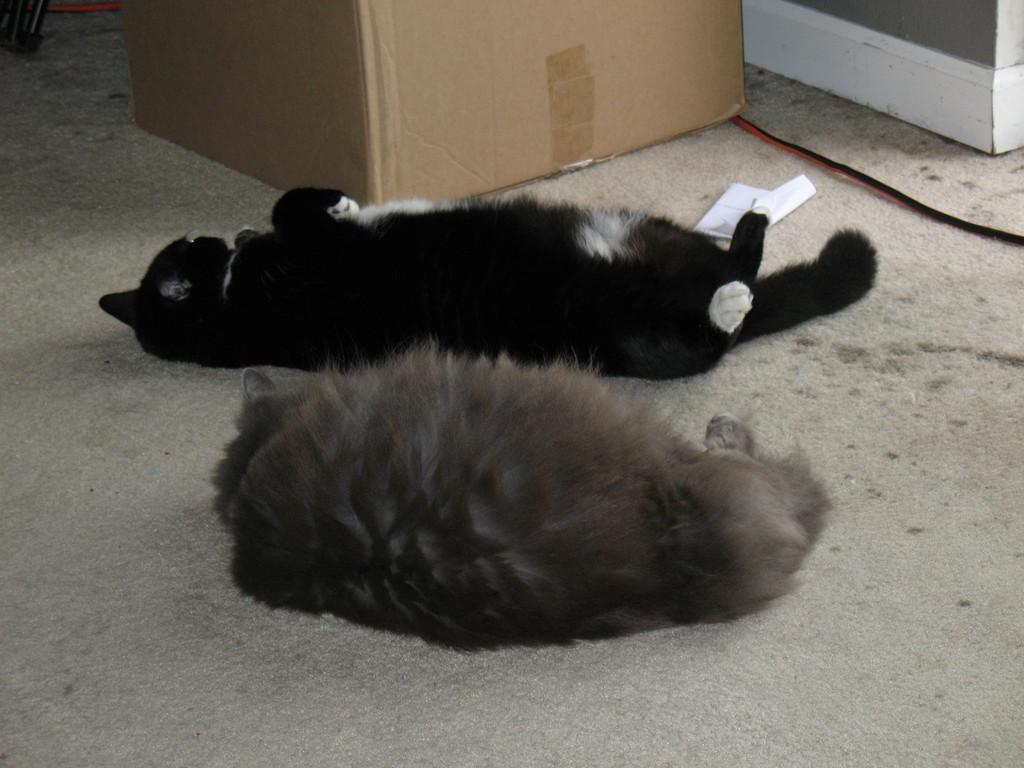In one or two sentences, can you explain what this image depicts? In this image I can see two animals and they are in brown and black color. Background I can see the cardboard box and the wall is in grey and white color. 